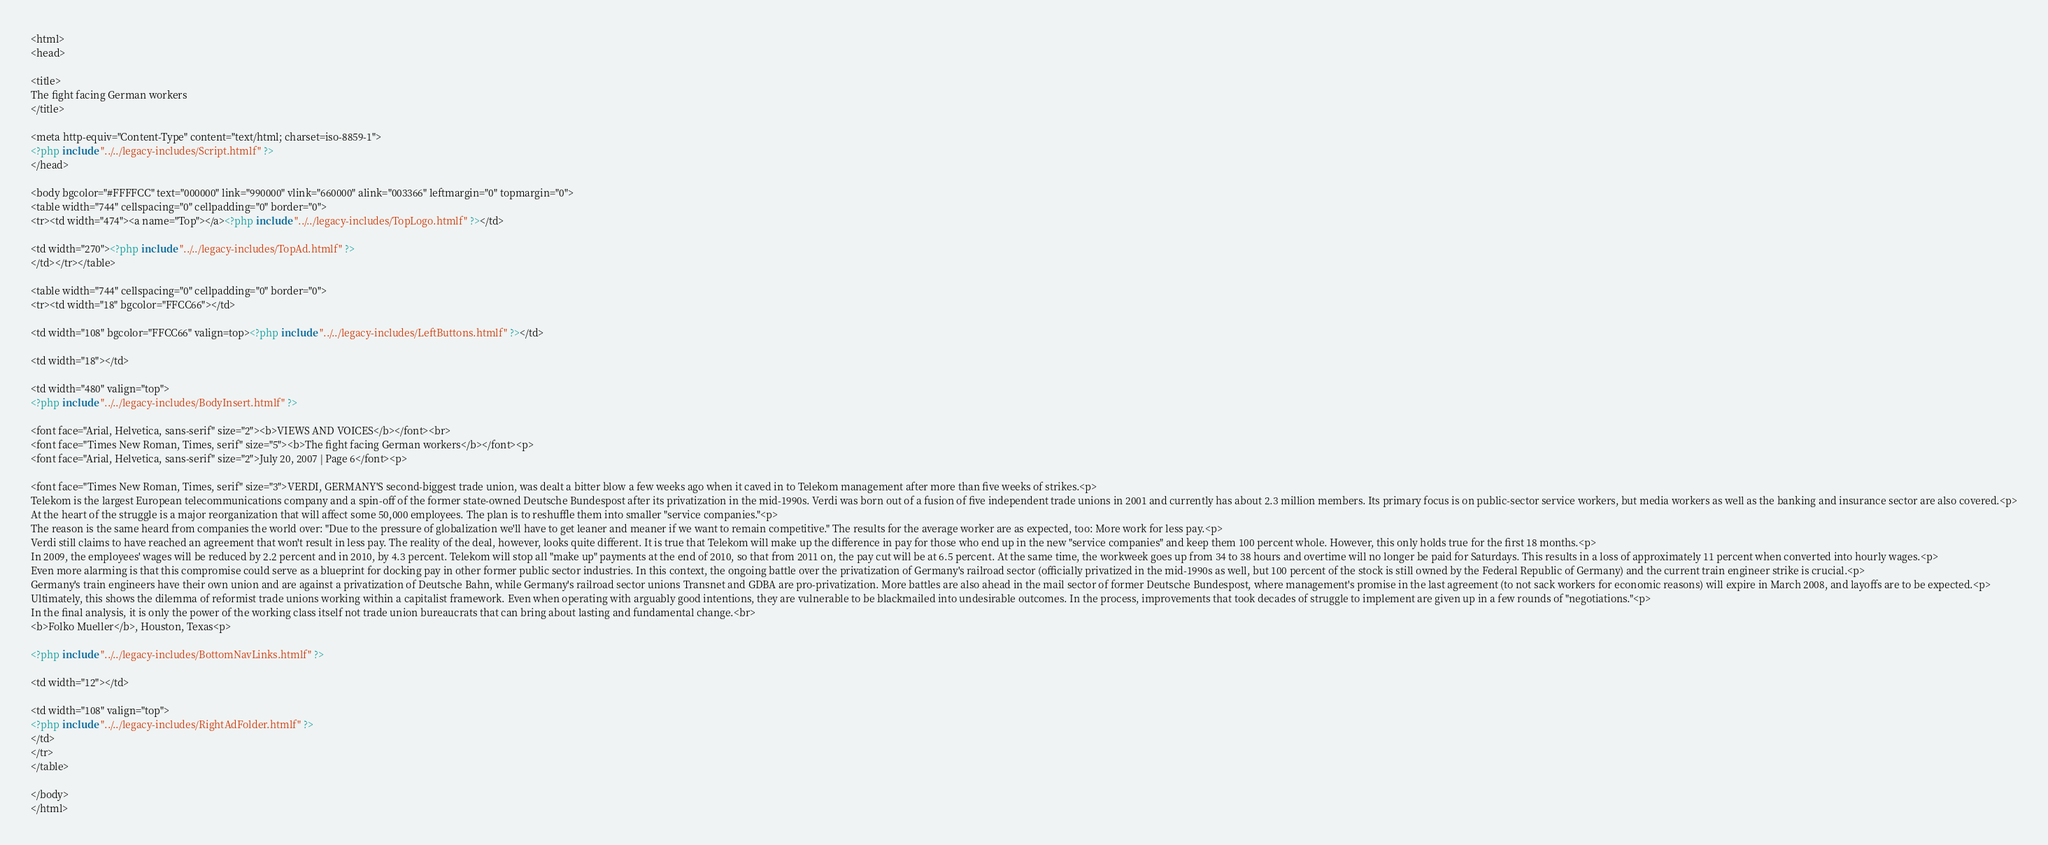Convert code to text. <code><loc_0><loc_0><loc_500><loc_500><_PHP_><html>
<head>

<title>
The fight facing German workers
</title>

<meta http-equiv="Content-Type" content="text/html; charset=iso-8859-1">
<?php include "../../legacy-includes/Script.htmlf" ?>
</head>

<body bgcolor="#FFFFCC" text="000000" link="990000" vlink="660000" alink="003366" leftmargin="0" topmargin="0">
<table width="744" cellspacing="0" cellpadding="0" border="0">
<tr><td width="474"><a name="Top"></a><?php include "../../legacy-includes/TopLogo.htmlf" ?></td>

<td width="270"><?php include "../../legacy-includes/TopAd.htmlf" ?>
</td></tr></table>

<table width="744" cellspacing="0" cellpadding="0" border="0">
<tr><td width="18" bgcolor="FFCC66"></td>

<td width="108" bgcolor="FFCC66" valign=top><?php include "../../legacy-includes/LeftButtons.htmlf" ?></td>

<td width="18"></td>

<td width="480" valign="top">
<?php include "../../legacy-includes/BodyInsert.htmlf" ?>

<font face="Arial, Helvetica, sans-serif" size="2"><b>VIEWS AND VOICES</b></font><br>
<font face="Times New Roman, Times, serif" size="5"><b>The fight facing German workers</b></font><p>
<font face="Arial, Helvetica, sans-serif" size="2">July 20, 2007 | Page 6</font><p>

<font face="Times New Roman, Times, serif" size="3">VERDI, GERMANY'S second-biggest trade union, was dealt a bitter blow a few weeks ago when it caved in to Telekom management after more than five weeks of strikes.<p>
Telekom is the largest European telecommunications company and a spin-off of the former state-owned Deutsche Bundespost after its privatization in the mid-1990s. Verdi was born out of a fusion of five independent trade unions in 2001 and currently has about 2.3 million members. Its primary focus is on public-sector service workers, but media workers as well as the banking and insurance sector are also covered.<p>
At the heart of the struggle is a major reorganization that will affect some 50,000 employees. The plan is to reshuffle them into smaller "service companies."<p>
The reason is the same heard from companies the world over: "Due to the pressure of globalization we'll have to get leaner and meaner if we want to remain competitive." The results for the average worker are as expected, too: More work for less pay.<p>
Verdi still claims to have reached an agreement that won't result in less pay. The reality of the deal, however, looks quite different. It is true that Telekom will make up the difference in pay for those who end up in the new "service companies" and keep them 100 percent whole. However, this only holds true for the first 18 months.<p>
In 2009, the employees' wages will be reduced by 2.2 percent and in 2010, by 4.3 percent. Telekom will stop all "make up" payments at the end of 2010, so that from 2011 on, the pay cut will be at 6.5 percent. At the same time, the workweek goes up from 34 to 38 hours and overtime will no longer be paid for Saturdays. This results in a loss of approximately 11 percent when converted into hourly wages.<p>
Even more alarming is that this compromise could serve as a blueprint for docking pay in other former public sector industries. In this context, the ongoing battle over the privatization of Germany's railroad sector (officially privatized in the mid-1990s as well, but 100 percent of the stock is still owned by the Federal Republic of Germany) and the current train engineer strike is crucial.<p>
Germany's train engineers have their own union and are against a privatization of Deutsche Bahn, while Germany's railroad sector unions Transnet and GDBA are pro-privatization. More battles are also ahead in the mail sector of former Deutsche Bundespost, where management's promise in the last agreement (to not sack workers for economic reasons) will expire in March 2008, and layoffs are to be expected.<p>
Ultimately, this shows the dilemma of reformist trade unions working within a capitalist framework. Even when operating with arguably good intentions, they are vulnerable to be blackmailed into undesirable outcomes. In the process, improvements that took decades of struggle to implement are given up in a few rounds of "negotiations."<p>
In the final analysis, it is only the power of the working class itself not trade union bureaucrats that can bring about lasting and fundamental change.<br>
<b>Folko Mueller</b>, Houston, Texas<p>

<?php include "../../legacy-includes/BottomNavLinks.htmlf" ?>

<td width="12"></td>

<td width="108" valign="top">
<?php include "../../legacy-includes/RightAdFolder.htmlf" ?>
</td>
</tr>
</table>

</body>
</html>
</code> 